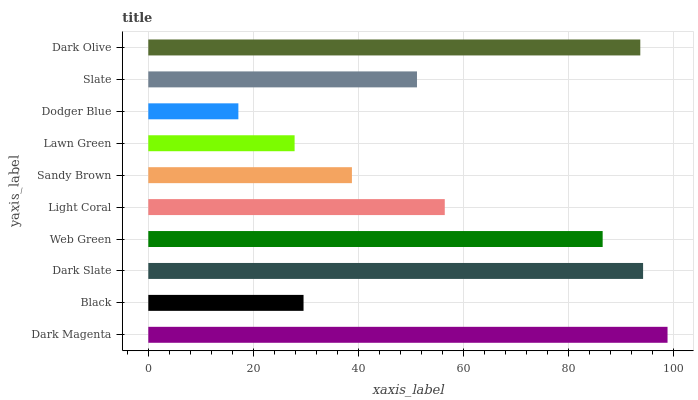Is Dodger Blue the minimum?
Answer yes or no. Yes. Is Dark Magenta the maximum?
Answer yes or no. Yes. Is Black the minimum?
Answer yes or no. No. Is Black the maximum?
Answer yes or no. No. Is Dark Magenta greater than Black?
Answer yes or no. Yes. Is Black less than Dark Magenta?
Answer yes or no. Yes. Is Black greater than Dark Magenta?
Answer yes or no. No. Is Dark Magenta less than Black?
Answer yes or no. No. Is Light Coral the high median?
Answer yes or no. Yes. Is Slate the low median?
Answer yes or no. Yes. Is Dodger Blue the high median?
Answer yes or no. No. Is Lawn Green the low median?
Answer yes or no. No. 